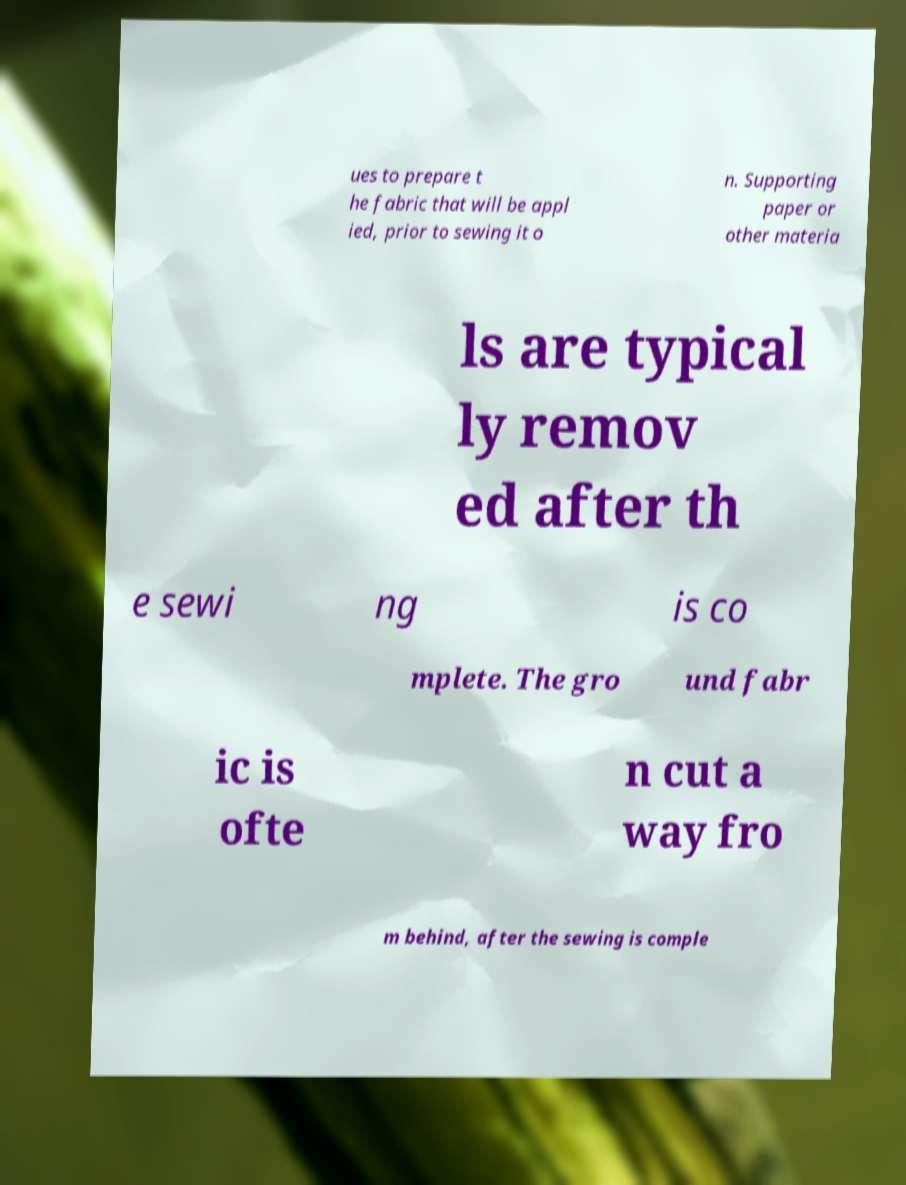Can you accurately transcribe the text from the provided image for me? ues to prepare t he fabric that will be appl ied, prior to sewing it o n. Supporting paper or other materia ls are typical ly remov ed after th e sewi ng is co mplete. The gro und fabr ic is ofte n cut a way fro m behind, after the sewing is comple 